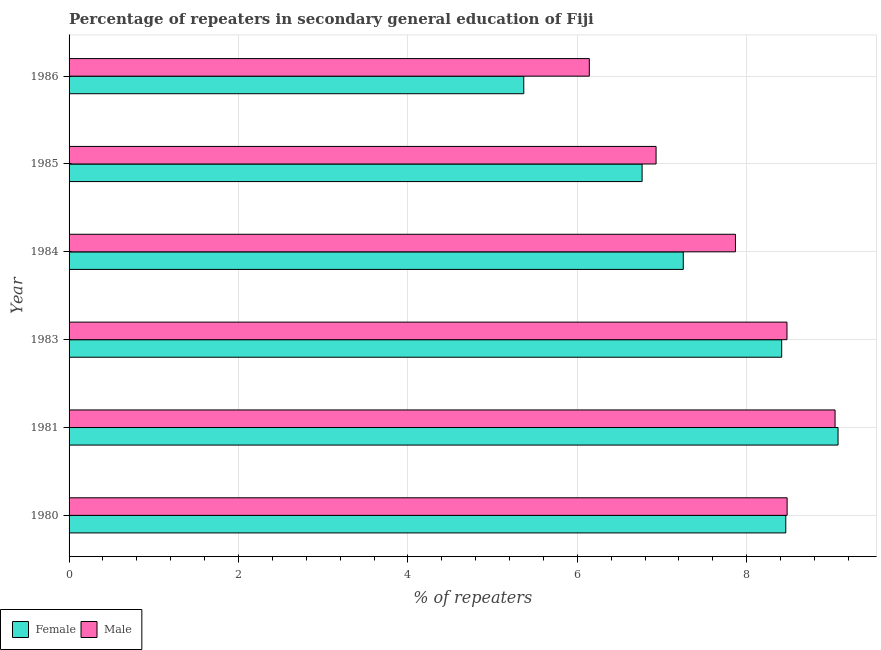How many groups of bars are there?
Make the answer very short. 6. Are the number of bars per tick equal to the number of legend labels?
Your answer should be compact. Yes. How many bars are there on the 3rd tick from the bottom?
Keep it short and to the point. 2. What is the label of the 4th group of bars from the top?
Your answer should be very brief. 1983. What is the percentage of male repeaters in 1984?
Make the answer very short. 7.87. Across all years, what is the maximum percentage of female repeaters?
Keep it short and to the point. 9.08. Across all years, what is the minimum percentage of female repeaters?
Give a very brief answer. 5.37. What is the total percentage of female repeaters in the graph?
Provide a short and direct response. 45.34. What is the difference between the percentage of male repeaters in 1980 and that in 1981?
Provide a short and direct response. -0.57. What is the difference between the percentage of male repeaters in 1981 and the percentage of female repeaters in 1983?
Provide a short and direct response. 0.63. What is the average percentage of male repeaters per year?
Make the answer very short. 7.82. In the year 1981, what is the difference between the percentage of male repeaters and percentage of female repeaters?
Provide a succinct answer. -0.04. What is the ratio of the percentage of female repeaters in 1984 to that in 1985?
Provide a succinct answer. 1.07. Is the percentage of male repeaters in 1981 less than that in 1983?
Provide a short and direct response. No. Is the difference between the percentage of female repeaters in 1983 and 1984 greater than the difference between the percentage of male repeaters in 1983 and 1984?
Your answer should be very brief. Yes. What is the difference between the highest and the second highest percentage of female repeaters?
Provide a short and direct response. 0.62. What is the difference between the highest and the lowest percentage of male repeaters?
Keep it short and to the point. 2.9. In how many years, is the percentage of male repeaters greater than the average percentage of male repeaters taken over all years?
Offer a terse response. 4. Are all the bars in the graph horizontal?
Your response must be concise. Yes. What is the difference between two consecutive major ticks on the X-axis?
Offer a very short reply. 2. Are the values on the major ticks of X-axis written in scientific E-notation?
Offer a terse response. No. Does the graph contain grids?
Your response must be concise. Yes. Where does the legend appear in the graph?
Your response must be concise. Bottom left. How are the legend labels stacked?
Give a very brief answer. Horizontal. What is the title of the graph?
Keep it short and to the point. Percentage of repeaters in secondary general education of Fiji. Does "Working only" appear as one of the legend labels in the graph?
Keep it short and to the point. No. What is the label or title of the X-axis?
Ensure brevity in your answer.  % of repeaters. What is the label or title of the Y-axis?
Your answer should be very brief. Year. What is the % of repeaters in Female in 1980?
Your answer should be compact. 8.46. What is the % of repeaters in Male in 1980?
Make the answer very short. 8.48. What is the % of repeaters in Female in 1981?
Make the answer very short. 9.08. What is the % of repeaters in Male in 1981?
Offer a very short reply. 9.04. What is the % of repeaters in Female in 1983?
Provide a short and direct response. 8.41. What is the % of repeaters in Male in 1983?
Your answer should be compact. 8.48. What is the % of repeaters in Female in 1984?
Ensure brevity in your answer.  7.25. What is the % of repeaters of Male in 1984?
Ensure brevity in your answer.  7.87. What is the % of repeaters in Female in 1985?
Provide a short and direct response. 6.76. What is the % of repeaters in Male in 1985?
Give a very brief answer. 6.93. What is the % of repeaters of Female in 1986?
Provide a short and direct response. 5.37. What is the % of repeaters in Male in 1986?
Provide a short and direct response. 6.14. Across all years, what is the maximum % of repeaters in Female?
Keep it short and to the point. 9.08. Across all years, what is the maximum % of repeaters of Male?
Your answer should be compact. 9.04. Across all years, what is the minimum % of repeaters of Female?
Your answer should be compact. 5.37. Across all years, what is the minimum % of repeaters in Male?
Give a very brief answer. 6.14. What is the total % of repeaters of Female in the graph?
Make the answer very short. 45.34. What is the total % of repeaters in Male in the graph?
Ensure brevity in your answer.  46.93. What is the difference between the % of repeaters of Female in 1980 and that in 1981?
Your response must be concise. -0.62. What is the difference between the % of repeaters in Male in 1980 and that in 1981?
Your answer should be very brief. -0.57. What is the difference between the % of repeaters in Female in 1980 and that in 1983?
Keep it short and to the point. 0.05. What is the difference between the % of repeaters of Male in 1980 and that in 1983?
Keep it short and to the point. 0. What is the difference between the % of repeaters of Female in 1980 and that in 1984?
Offer a very short reply. 1.21. What is the difference between the % of repeaters in Male in 1980 and that in 1984?
Your answer should be compact. 0.61. What is the difference between the % of repeaters in Female in 1980 and that in 1985?
Make the answer very short. 1.7. What is the difference between the % of repeaters in Male in 1980 and that in 1985?
Make the answer very short. 1.55. What is the difference between the % of repeaters in Female in 1980 and that in 1986?
Provide a succinct answer. 3.09. What is the difference between the % of repeaters in Male in 1980 and that in 1986?
Give a very brief answer. 2.34. What is the difference between the % of repeaters of Female in 1981 and that in 1983?
Ensure brevity in your answer.  0.67. What is the difference between the % of repeaters of Male in 1981 and that in 1983?
Give a very brief answer. 0.57. What is the difference between the % of repeaters of Female in 1981 and that in 1984?
Your answer should be very brief. 1.83. What is the difference between the % of repeaters of Male in 1981 and that in 1984?
Offer a terse response. 1.18. What is the difference between the % of repeaters in Female in 1981 and that in 1985?
Offer a terse response. 2.31. What is the difference between the % of repeaters in Male in 1981 and that in 1985?
Your answer should be compact. 2.11. What is the difference between the % of repeaters in Female in 1981 and that in 1986?
Offer a very short reply. 3.71. What is the difference between the % of repeaters in Male in 1981 and that in 1986?
Provide a succinct answer. 2.9. What is the difference between the % of repeaters of Female in 1983 and that in 1984?
Provide a short and direct response. 1.16. What is the difference between the % of repeaters in Male in 1983 and that in 1984?
Your answer should be compact. 0.61. What is the difference between the % of repeaters in Female in 1983 and that in 1985?
Provide a short and direct response. 1.65. What is the difference between the % of repeaters of Male in 1983 and that in 1985?
Keep it short and to the point. 1.55. What is the difference between the % of repeaters of Female in 1983 and that in 1986?
Offer a very short reply. 3.04. What is the difference between the % of repeaters in Male in 1983 and that in 1986?
Provide a succinct answer. 2.33. What is the difference between the % of repeaters in Female in 1984 and that in 1985?
Your response must be concise. 0.49. What is the difference between the % of repeaters of Male in 1984 and that in 1985?
Your answer should be compact. 0.94. What is the difference between the % of repeaters of Female in 1984 and that in 1986?
Provide a succinct answer. 1.88. What is the difference between the % of repeaters in Male in 1984 and that in 1986?
Offer a very short reply. 1.73. What is the difference between the % of repeaters of Female in 1985 and that in 1986?
Provide a succinct answer. 1.4. What is the difference between the % of repeaters in Male in 1985 and that in 1986?
Ensure brevity in your answer.  0.79. What is the difference between the % of repeaters in Female in 1980 and the % of repeaters in Male in 1981?
Ensure brevity in your answer.  -0.58. What is the difference between the % of repeaters in Female in 1980 and the % of repeaters in Male in 1983?
Ensure brevity in your answer.  -0.01. What is the difference between the % of repeaters in Female in 1980 and the % of repeaters in Male in 1984?
Make the answer very short. 0.59. What is the difference between the % of repeaters of Female in 1980 and the % of repeaters of Male in 1985?
Provide a short and direct response. 1.53. What is the difference between the % of repeaters of Female in 1980 and the % of repeaters of Male in 1986?
Provide a short and direct response. 2.32. What is the difference between the % of repeaters in Female in 1981 and the % of repeaters in Male in 1983?
Keep it short and to the point. 0.6. What is the difference between the % of repeaters in Female in 1981 and the % of repeaters in Male in 1984?
Provide a succinct answer. 1.21. What is the difference between the % of repeaters in Female in 1981 and the % of repeaters in Male in 1985?
Keep it short and to the point. 2.15. What is the difference between the % of repeaters in Female in 1981 and the % of repeaters in Male in 1986?
Provide a short and direct response. 2.94. What is the difference between the % of repeaters of Female in 1983 and the % of repeaters of Male in 1984?
Provide a short and direct response. 0.55. What is the difference between the % of repeaters in Female in 1983 and the % of repeaters in Male in 1985?
Ensure brevity in your answer.  1.48. What is the difference between the % of repeaters of Female in 1983 and the % of repeaters of Male in 1986?
Keep it short and to the point. 2.27. What is the difference between the % of repeaters of Female in 1984 and the % of repeaters of Male in 1985?
Offer a very short reply. 0.32. What is the difference between the % of repeaters in Female in 1984 and the % of repeaters in Male in 1986?
Offer a terse response. 1.11. What is the difference between the % of repeaters of Female in 1985 and the % of repeaters of Male in 1986?
Offer a very short reply. 0.62. What is the average % of repeaters in Female per year?
Ensure brevity in your answer.  7.56. What is the average % of repeaters of Male per year?
Your answer should be compact. 7.82. In the year 1980, what is the difference between the % of repeaters of Female and % of repeaters of Male?
Your answer should be compact. -0.02. In the year 1981, what is the difference between the % of repeaters in Female and % of repeaters in Male?
Your answer should be compact. 0.04. In the year 1983, what is the difference between the % of repeaters in Female and % of repeaters in Male?
Offer a very short reply. -0.06. In the year 1984, what is the difference between the % of repeaters in Female and % of repeaters in Male?
Your response must be concise. -0.62. In the year 1985, what is the difference between the % of repeaters of Female and % of repeaters of Male?
Provide a succinct answer. -0.17. In the year 1986, what is the difference between the % of repeaters of Female and % of repeaters of Male?
Your answer should be very brief. -0.77. What is the ratio of the % of repeaters of Female in 1980 to that in 1981?
Your answer should be very brief. 0.93. What is the ratio of the % of repeaters in Male in 1980 to that in 1981?
Your response must be concise. 0.94. What is the ratio of the % of repeaters of Female in 1980 to that in 1983?
Keep it short and to the point. 1.01. What is the ratio of the % of repeaters of Male in 1980 to that in 1983?
Make the answer very short. 1. What is the ratio of the % of repeaters of Female in 1980 to that in 1984?
Offer a very short reply. 1.17. What is the ratio of the % of repeaters of Male in 1980 to that in 1984?
Make the answer very short. 1.08. What is the ratio of the % of repeaters of Female in 1980 to that in 1985?
Make the answer very short. 1.25. What is the ratio of the % of repeaters in Male in 1980 to that in 1985?
Give a very brief answer. 1.22. What is the ratio of the % of repeaters in Female in 1980 to that in 1986?
Provide a succinct answer. 1.58. What is the ratio of the % of repeaters in Male in 1980 to that in 1986?
Your answer should be very brief. 1.38. What is the ratio of the % of repeaters in Female in 1981 to that in 1983?
Your answer should be compact. 1.08. What is the ratio of the % of repeaters of Male in 1981 to that in 1983?
Your response must be concise. 1.07. What is the ratio of the % of repeaters in Female in 1981 to that in 1984?
Offer a terse response. 1.25. What is the ratio of the % of repeaters of Male in 1981 to that in 1984?
Offer a very short reply. 1.15. What is the ratio of the % of repeaters in Female in 1981 to that in 1985?
Keep it short and to the point. 1.34. What is the ratio of the % of repeaters of Male in 1981 to that in 1985?
Make the answer very short. 1.3. What is the ratio of the % of repeaters in Female in 1981 to that in 1986?
Your response must be concise. 1.69. What is the ratio of the % of repeaters of Male in 1981 to that in 1986?
Ensure brevity in your answer.  1.47. What is the ratio of the % of repeaters of Female in 1983 to that in 1984?
Ensure brevity in your answer.  1.16. What is the ratio of the % of repeaters of Male in 1983 to that in 1984?
Keep it short and to the point. 1.08. What is the ratio of the % of repeaters of Female in 1983 to that in 1985?
Keep it short and to the point. 1.24. What is the ratio of the % of repeaters in Male in 1983 to that in 1985?
Keep it short and to the point. 1.22. What is the ratio of the % of repeaters in Female in 1983 to that in 1986?
Provide a short and direct response. 1.57. What is the ratio of the % of repeaters of Male in 1983 to that in 1986?
Offer a very short reply. 1.38. What is the ratio of the % of repeaters in Female in 1984 to that in 1985?
Offer a terse response. 1.07. What is the ratio of the % of repeaters in Male in 1984 to that in 1985?
Make the answer very short. 1.14. What is the ratio of the % of repeaters in Female in 1984 to that in 1986?
Your answer should be compact. 1.35. What is the ratio of the % of repeaters in Male in 1984 to that in 1986?
Keep it short and to the point. 1.28. What is the ratio of the % of repeaters of Female in 1985 to that in 1986?
Give a very brief answer. 1.26. What is the ratio of the % of repeaters of Male in 1985 to that in 1986?
Provide a short and direct response. 1.13. What is the difference between the highest and the second highest % of repeaters of Female?
Keep it short and to the point. 0.62. What is the difference between the highest and the second highest % of repeaters in Male?
Your response must be concise. 0.57. What is the difference between the highest and the lowest % of repeaters in Female?
Give a very brief answer. 3.71. What is the difference between the highest and the lowest % of repeaters of Male?
Provide a succinct answer. 2.9. 